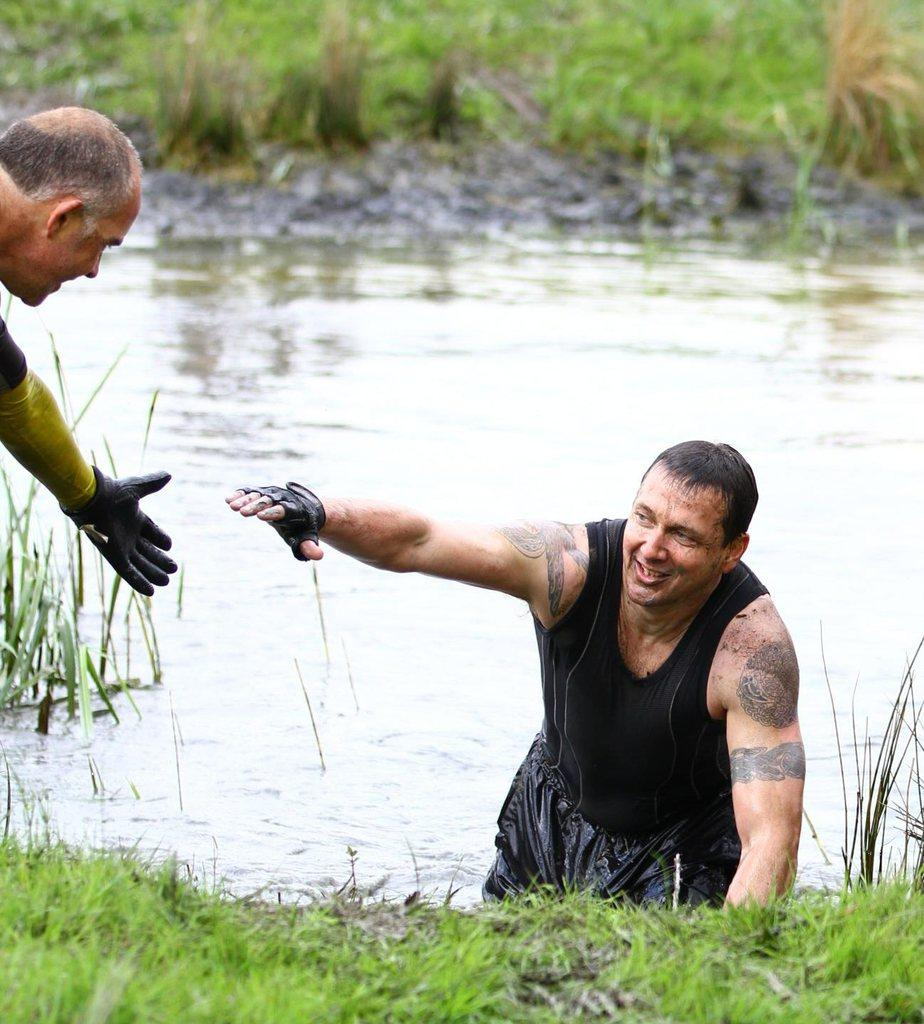What is the position of the man in the image? There is a man standing in the image, and another man standing in the water. How is the man in the water feeling? The man in the water is smiling. What can be seen in the background of the image? There are plants visible in the background of the image. What is visible at the bottom of the image? There is water and grass visible at the bottom of the image. What type of hole can be seen in the image? There is no hole present in the image. What kind of slope can be seen in the image? There is no slope present in the image. 